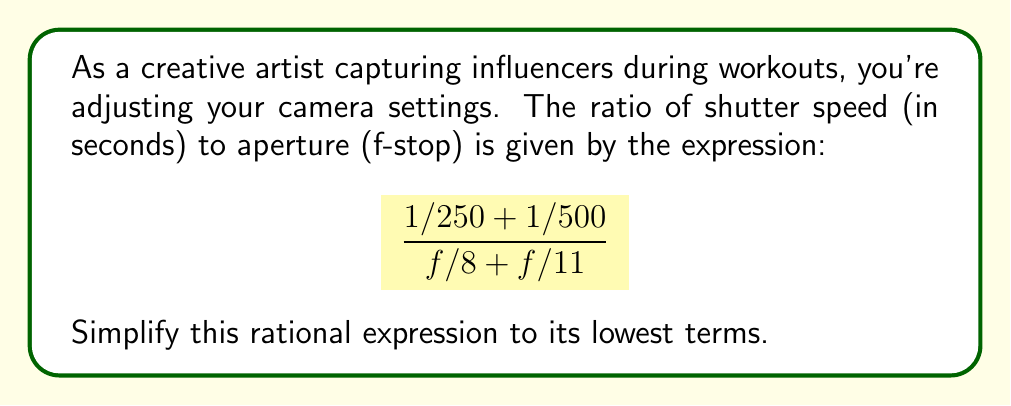Could you help me with this problem? Let's simplify this rational expression step by step:

1) First, let's simplify the numerator:
   $$\frac{1}{250} + \frac{1}{500} = \frac{2}{500} + \frac{1}{500} = \frac{3}{500}$$

2) Now, let's simplify the denominator:
   $$\frac{f}{8} + \frac{f}{11} = \frac{11f}{88} + \frac{8f}{88} = \frac{19f}{88}$$

3) Our expression now looks like this:
   $$\frac{3/500}{19f/88}$$

4) To divide fractions, we multiply by the reciprocal:
   $$\frac{3/500}{19f/88} = \frac{3}{500} \cdot \frac{88}{19f} = \frac{3 \cdot 88}{500 \cdot 19f} = \frac{264}{9500f}$$

5) We can further simplify by dividing both numerator and denominator by their greatest common divisor (GCD):
   The GCD of 264 and 9500 is 4.
   
   $$\frac{264}{9500f} = \frac{264 \div 4}{9500f \div 4} = \frac{66}{2375f}$$

This is now in its simplest form.
Answer: $$\frac{66}{2375f}$$ 